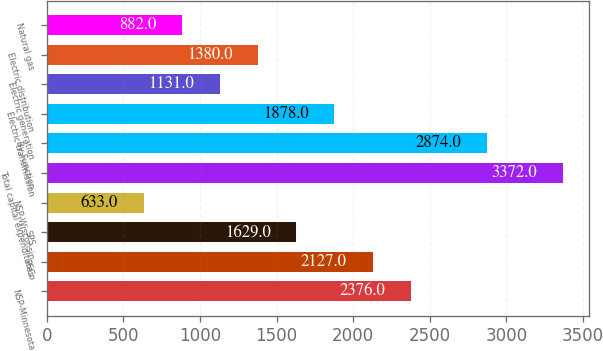Convert chart to OTSL. <chart><loc_0><loc_0><loc_500><loc_500><bar_chart><fcel>NSP-Minnesota<fcel>PSCo<fcel>SPS<fcel>NSP-Wisconsin<fcel>Total capital expenditures<fcel>By Function<fcel>Electric transmission<fcel>Electric generation<fcel>Electric distribution<fcel>Natural gas<nl><fcel>2376<fcel>2127<fcel>1629<fcel>633<fcel>3372<fcel>2874<fcel>1878<fcel>1131<fcel>1380<fcel>882<nl></chart> 